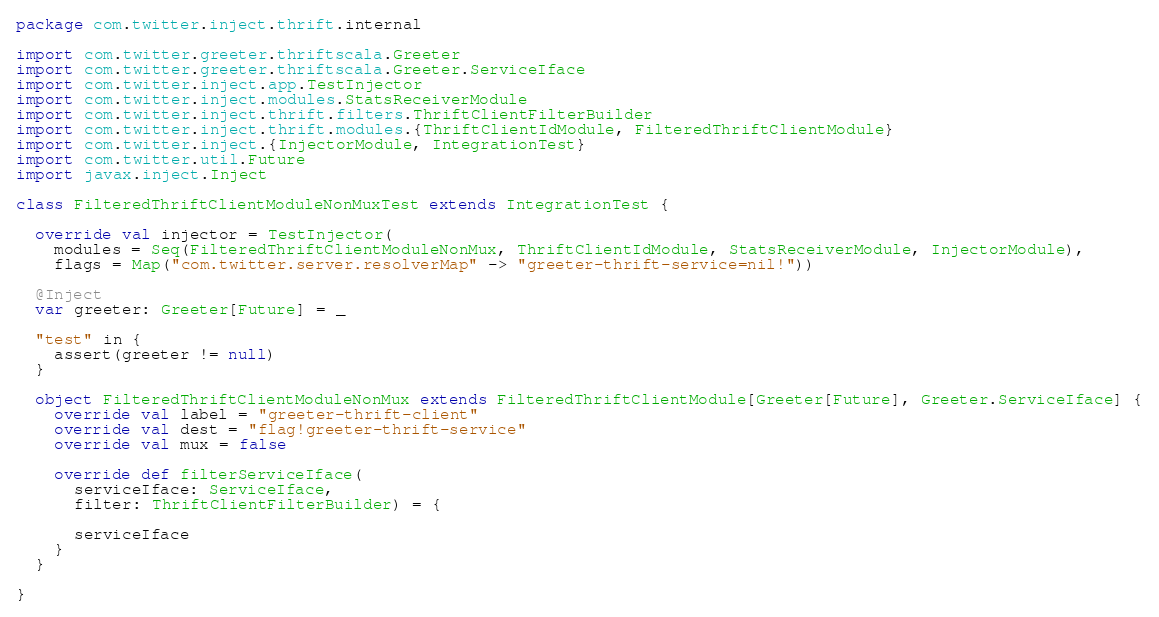<code> <loc_0><loc_0><loc_500><loc_500><_Scala_>package com.twitter.inject.thrift.internal

import com.twitter.greeter.thriftscala.Greeter
import com.twitter.greeter.thriftscala.Greeter.ServiceIface
import com.twitter.inject.app.TestInjector
import com.twitter.inject.modules.StatsReceiverModule
import com.twitter.inject.thrift.filters.ThriftClientFilterBuilder
import com.twitter.inject.thrift.modules.{ThriftClientIdModule, FilteredThriftClientModule}
import com.twitter.inject.{InjectorModule, IntegrationTest}
import com.twitter.util.Future
import javax.inject.Inject

class FilteredThriftClientModuleNonMuxTest extends IntegrationTest {

  override val injector = TestInjector(
    modules = Seq(FilteredThriftClientModuleNonMux, ThriftClientIdModule, StatsReceiverModule, InjectorModule),
    flags = Map("com.twitter.server.resolverMap" -> "greeter-thrift-service=nil!"))

  @Inject
  var greeter: Greeter[Future] = _

  "test" in {
    assert(greeter != null)
  }

  object FilteredThriftClientModuleNonMux extends FilteredThriftClientModule[Greeter[Future], Greeter.ServiceIface] {
    override val label = "greeter-thrift-client"
    override val dest = "flag!greeter-thrift-service"
    override val mux = false

    override def filterServiceIface(
      serviceIface: ServiceIface,
      filter: ThriftClientFilterBuilder) = {

      serviceIface
    }
  }

}
</code> 